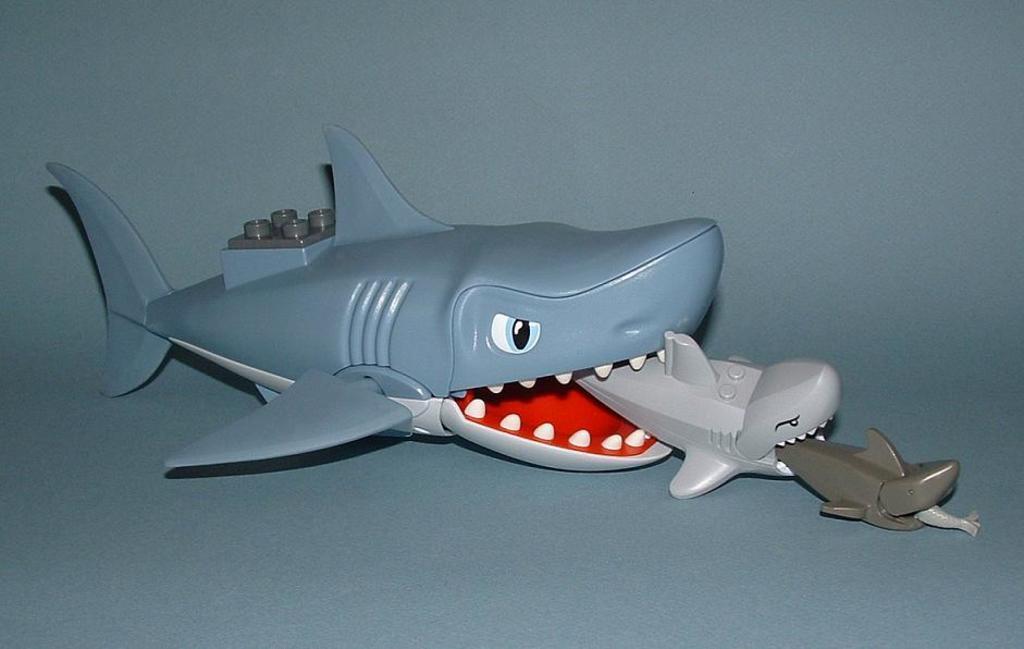Please provide a concise description of this image. In the image there are toys of sharks. 